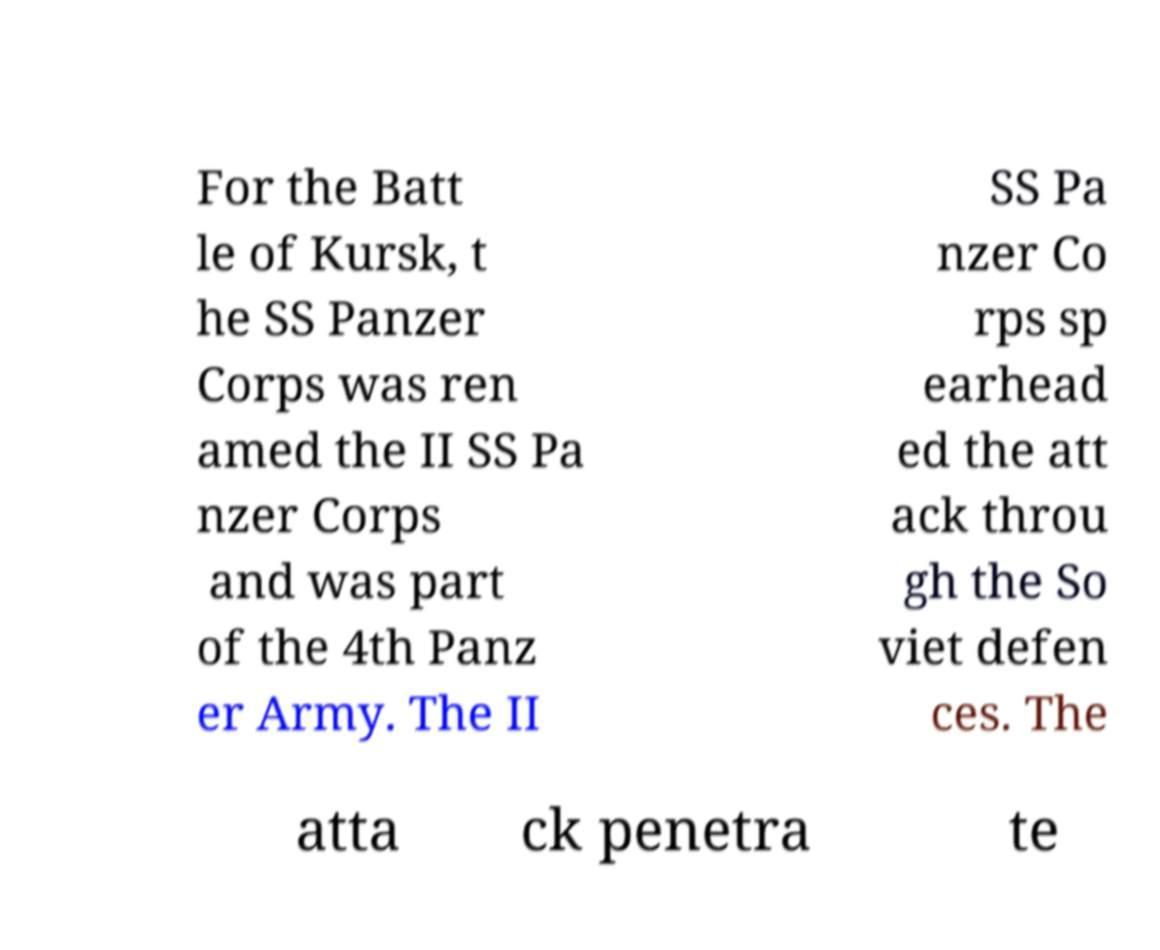Can you accurately transcribe the text from the provided image for me? For the Batt le of Kursk, t he SS Panzer Corps was ren amed the II SS Pa nzer Corps and was part of the 4th Panz er Army. The II SS Pa nzer Co rps sp earhead ed the att ack throu gh the So viet defen ces. The atta ck penetra te 